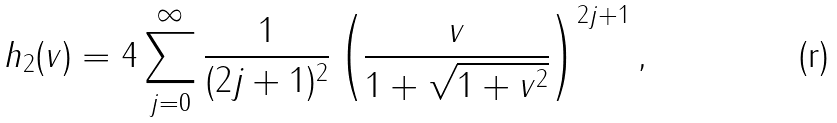Convert formula to latex. <formula><loc_0><loc_0><loc_500><loc_500>h _ { 2 } ( v ) = 4 \sum _ { j = 0 } ^ { \infty } \frac { 1 } { ( 2 j + 1 ) ^ { 2 } } \left ( \frac { v } { 1 + \sqrt { 1 + v ^ { 2 } } } \right ) ^ { 2 j + 1 } ,</formula> 